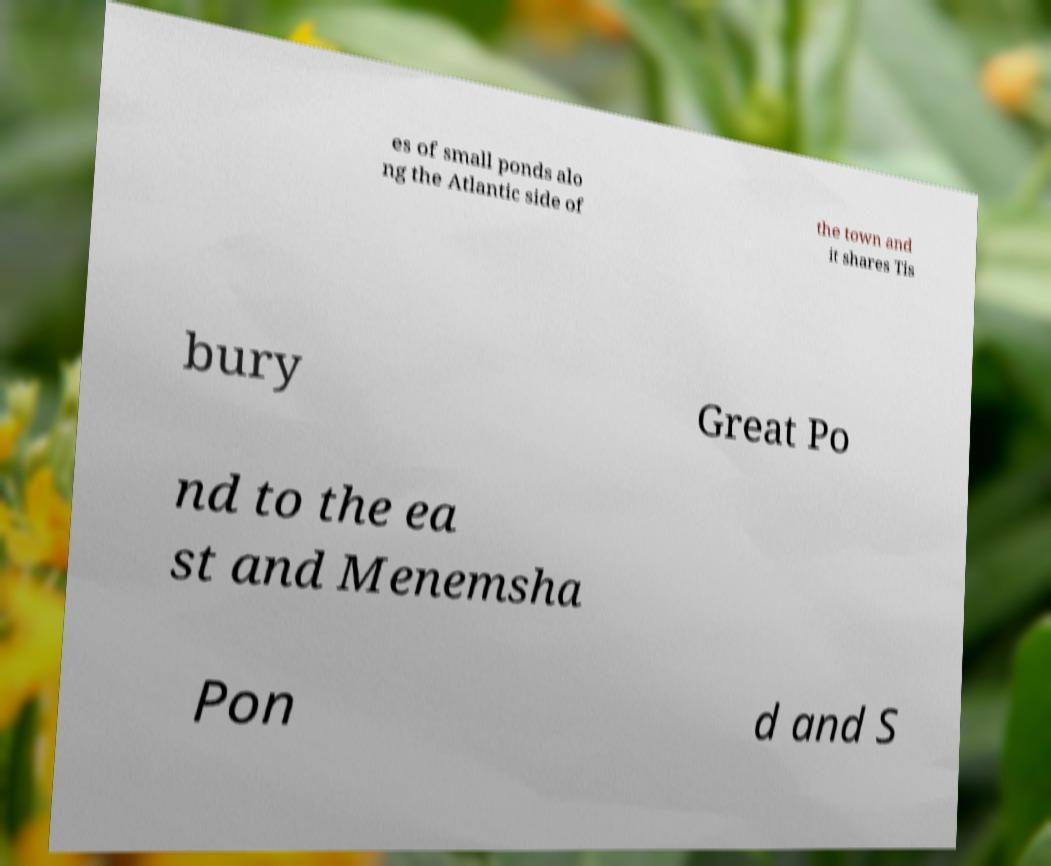I need the written content from this picture converted into text. Can you do that? es of small ponds alo ng the Atlantic side of the town and it shares Tis bury Great Po nd to the ea st and Menemsha Pon d and S 